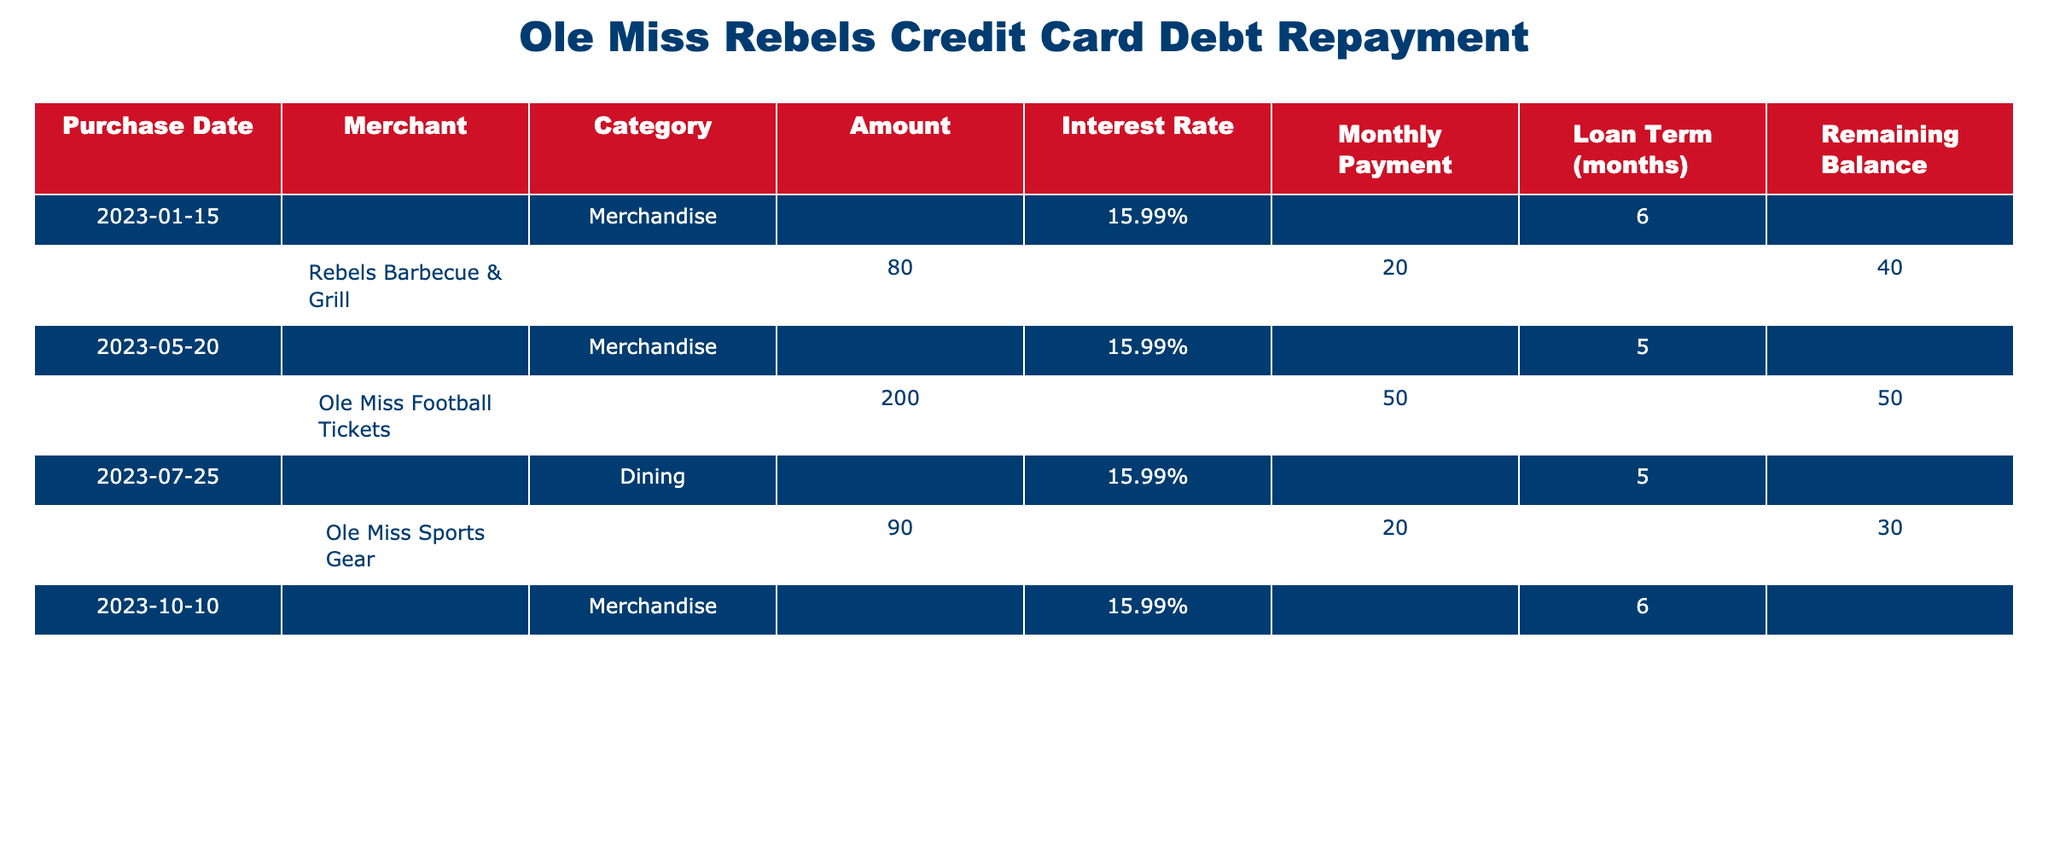What was the total amount spent on merchandise purchases? The merchandise purchases include amounts from the Ole Miss Team Store ($150), Rebels Apparel ($120), Ole Miss Sports Gear ($90), and Rebels Fan Shop ($110). Summing these gives $150 + $120 + $90 + $110 = $470.
Answer: 470 How many purchases are related to dining? There are two purchases related to dining: at Rebels Barbecue & Grill ($80) on March 10 and The Grove Cafe ($70) on July 25. Therefore, the total number of dining purchases is 2.
Answer: 2 What is the remaining balance for the Ole Miss Football Tickets purchase? The remaining balance for the Ole Miss Football Tickets purchase is recorded as $50 in the table.
Answer: 50 Which purchase has the highest interest rate? All purchases have the same interest rate of 15.99%. Hence, there is no single purchase with a higher interest rate.
Answer: No What is the average monthly payment across all purchases? The monthly payments are $25.00, $20.00, $30.00, $50.00, $15.00, $20.00, and $25.00. Adding these values gives $25 + $20 + $30 + $50 + $15 + $20 + $25 = $185. Dividing by the number of payments (7) gives an average of $185/7 ≈ $26.43.
Answer: 26.43 How many months are left to pay off the Rebels Barbecue & Grill dining purchase? The loan term for this purchase is 4 months, and the remaining balance is $40, indicating it is still being paid off. Therefore, there are 2 months left to complete (since it's now 2 months into the term).
Answer: 2 Is the amount for the last purchase fully paid off? The last purchase at the Rebels Fan Shop shows a remaining balance of $80, indicating it is not fully paid off.
Answer: No What is the total remaining balance for all purchases? The remaining balances are $100, $40, $60, $50, $0, $30, and $80. Adding these balances gives $100 + $40 + $60 + $50 + $0 + $30 + $80 = $360.
Answer: 360 How much did the Ole Miss Team Store purchase reduce the overall balance? The Ole Miss Team Store purchase started at $150 with an initial monthly payment of $25. After six months, since the remaining balance is $100, the repayment decreased it by $50 ($150 - $100) in total.
Answer: 50 